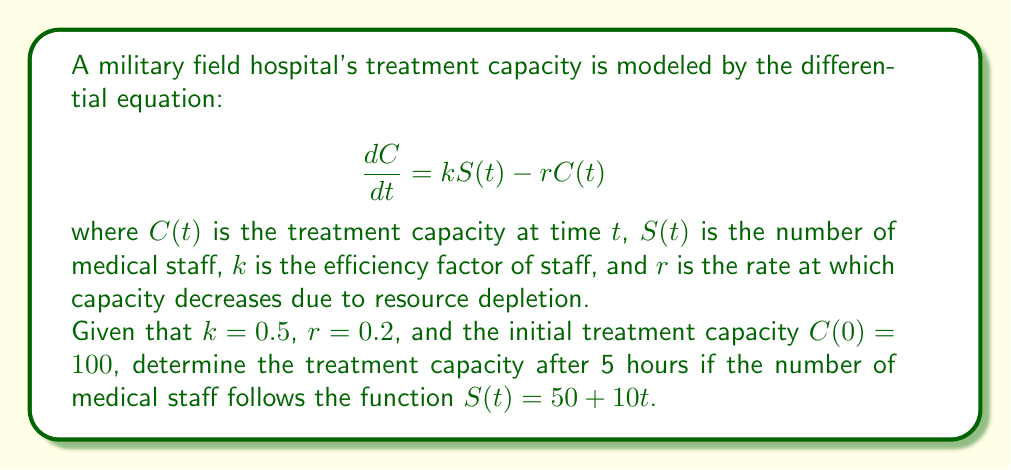Help me with this question. To solve this first-order linear differential equation, we'll use the integrating factor method:

1) The equation is in the form: $\frac{dC}{dt} + rC = kS(t)$

2) The integrating factor is $e^{\int r dt} = e^{rt}$

3) Multiply both sides by the integrating factor:
   $e^{rt}\frac{dC}{dt} + re^{rt}C = ke^{rt}S(t)$

4) The left side is now the derivative of $e^{rt}C$:
   $\frac{d}{dt}(e^{rt}C) = ke^{rt}S(t)$

5) Integrate both sides:
   $e^{rt}C = k\int e^{rt}S(t)dt + D$

6) Substitute $S(t) = 50 + 10t$:
   $e^{rt}C = k\int e^{rt}(50 + 10t)dt + D$

7) Integrate:
   $e^{rt}C = k[\frac{50}{r}e^{rt} + \frac{10}{r^2}e^{rt} - \frac{10t}{r}e^{rt}] + D$

8) Solve for $C$:
   $C = k[\frac{50}{r} + \frac{10}{r^2} - \frac{10t}{r}] + De^{-rt}$

9) Use the initial condition $C(0) = 100$ to find $D$:
   $100 = k[\frac{50}{r} + \frac{10}{r^2}] + D$
   $D = 100 - k[\frac{50}{r} + \frac{10}{r^2}]$

10) Substitute the values $k = 0.5$, $r = 0.2$:
    $C(t) = 0.5[\frac{50}{0.2} + \frac{10}{0.2^2} - \frac{10t}{0.2}] + (100 - 0.5[\frac{50}{0.2} + \frac{10}{0.2^2}])e^{-0.2t}$

11) Simplify:
    $C(t) = 125 + 125 - 25t + (100 - 250 - 125)e^{-0.2t}$
    $C(t) = 250 - 25t - 275e^{-0.2t}$

12) Calculate $C(5)$:
    $C(5) = 250 - 25(5) - 275e^{-0.2(5)}$
    $C(5) = 250 - 125 - 275e^{-1}$
    $C(5) = 125 - 275e^{-1} \approx 23.85$
Answer: The treatment capacity after 5 hours is approximately 23.85 units. 